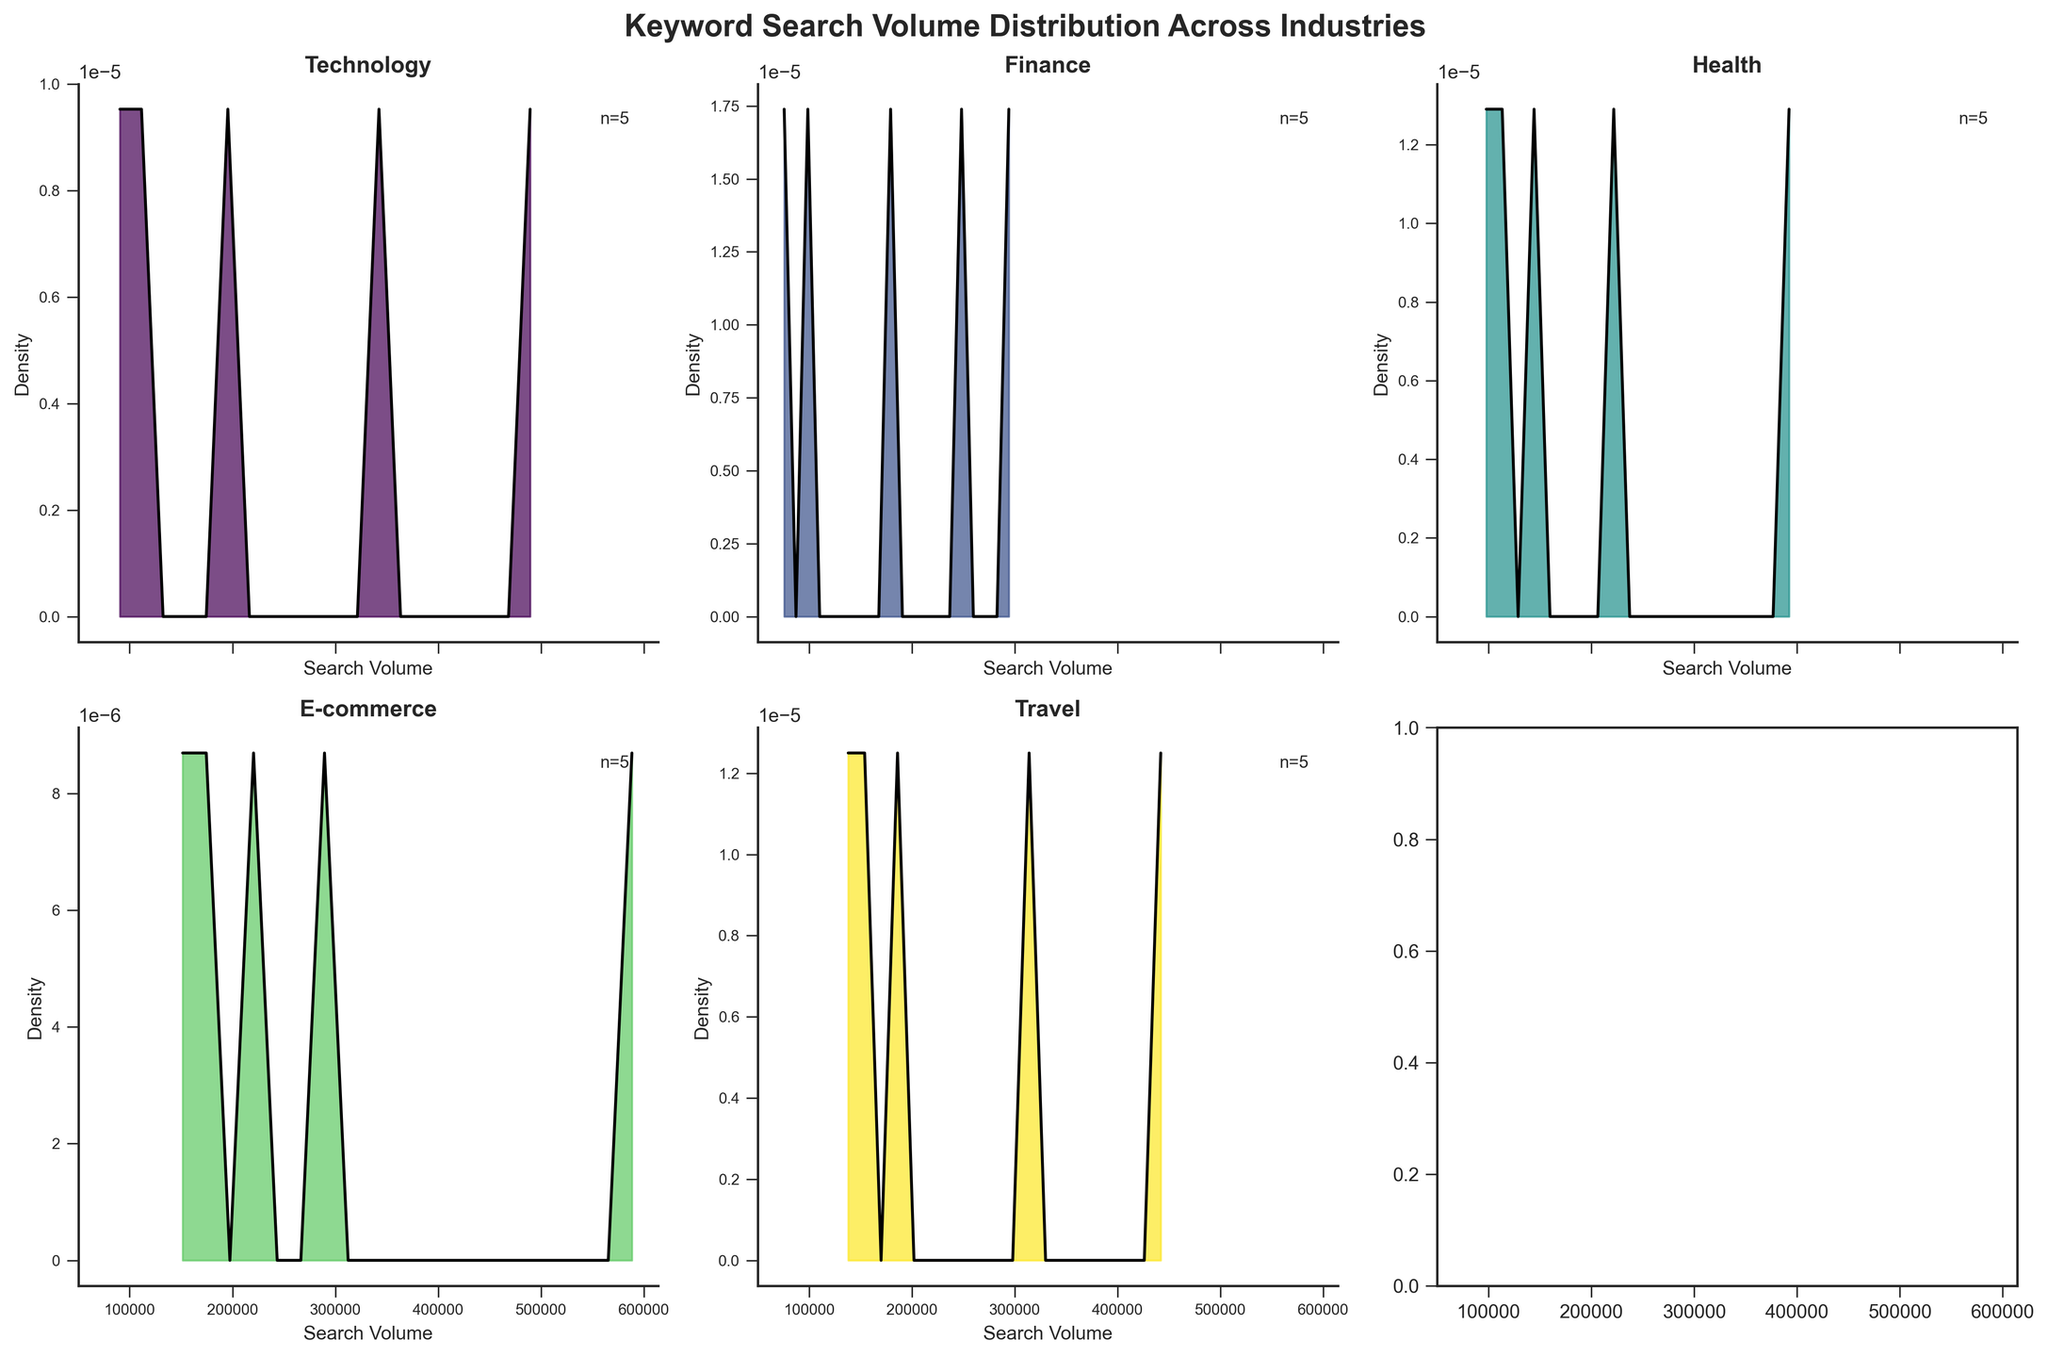What is the title of the figure? The title of the figure is written prominently at the top of the chart. It reads "Keyword Search Volume Distribution Across Industries."
Answer: Keyword Search Volume Distribution Across Industries Which industry has the highest single keyword search volume density? Looking at the density peaks in each subplot, the E-commerce industry's density plot has the highest peak, indicating the highest single keyword search volume density.
Answer: E-commerce How many search volume data points are there in the Health industry? In the Health industry's subplot, there's a text label indicating the number of data points with the notation 'n='. The number next to 'n=' is 5.
Answer: 5 Which industry's density plot shows the least spread in search volume? The spread of the density plot is indicated by the width of the plot: a narrow plot indicates less spread. The Finance industry has the narrowest density plot, implying the least spread in search volume.
Answer: Finance Compare the peak density values of the Technology and Travel industries. Which one is higher? The density plots of both industries show peaks. By comparing the height of these peaks, it is evident that the Technology industry's peak density value is higher than that of the Travel industry.
Answer: Technology What is the typical range of search volumes in the Technology industry? The axis labeled 'Search Volume' beneath the Technology subplot shows that the dense region of the plot (where most keyword search volumes fall) typically ranges from 80,000 to 500,000.
Answer: 80,000 to 500,000 Between E-commerce and Finance industries, which one has a broader range of search volumes? The range of search volumes is indicated by how spread out the density plots are on the x-axis. The E-commerce industry has a density plot that stretches from around 140,000 to 600,000, whereas Finance stretches from about 70,000 to 300,000, indicating E-commerce has a broader range.
Answer: E-commerce Which industry has the least skewed search volume distribution? The skewness of distribution can be visualized by the symmetry of the density plot. The Health industry's density plot appears to be the most symmetrical, indicating the least skewed distribution.
Answer: Health Among the given industries, how many have their peak density values above 0.00002? By examining the peak density values in each subplot, it is found that Technology, Finance, and Health have peak densities above 0.00002. Counting them gives us three industries.
Answer: 3 